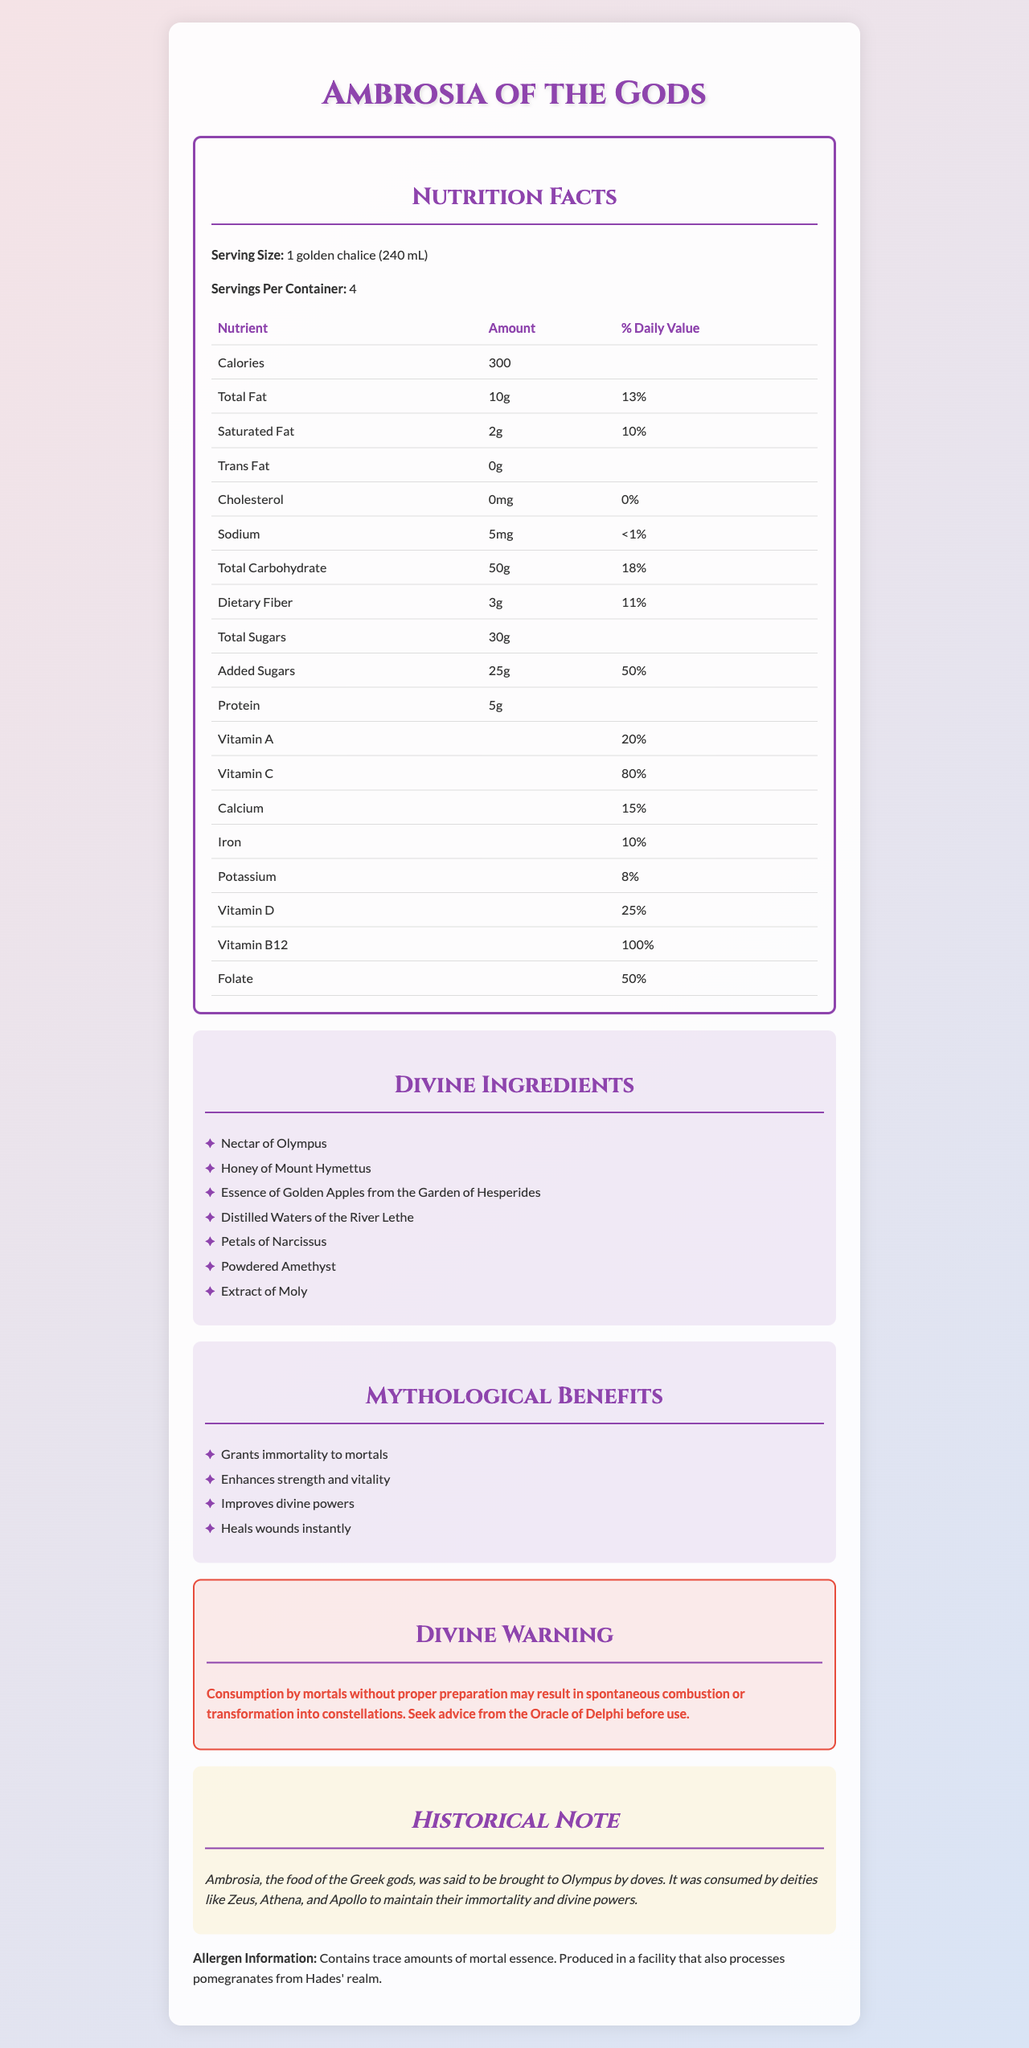What is the serving size of Ambrosia of the Gods? The serving size is clearly indicated as "1 golden chalice (240 mL)" in the Nutrition Facts section.
Answer: 1 golden chalice (240 mL) How many calories are in one serving of Ambrosia of the Gods? The Nutrition Facts section lists the calories per serving as 300.
Answer: 300 What is the daily value percentage for Vitamin C? The document shows the daily value percentage for Vitamin C as 80%.
Answer: 80% What are the mythological benefits of consuming Ambrosia of the Gods? The mythological benefits are listed in the Mythological Benefits section.
Answer: Grants immortality to mortals, Enhances strength and vitality, Improves divine powers, Heals wounds instantly What is a major warning for mortals consuming Ambrosia of the Gods? The warning is detailed under the Divine Warning section.
Answer: Consumption by mortals without proper preparation may result in spontaneous combustion or transformation into constellations How many servings are there per container of Ambrosia of the Gods? A. 2 B. 4 C. 6 The document specifies that there are 4 servings per container.
Answer: B Which ingredient is used in Ambrosia of the Gods? A. Nectar of Olympus B. Ambrosia Flowers C. Essence of Phoenix The ingredient "Nectar of Olympus" is listed in the Divine Ingredients section.
Answer: A Does Ambrosia of the Gods contain any cholesterol? The Nutrition Facts state that the cholesterol amount is 0mg, and the daily value is 0%.
Answer: No Can we determine the exact preparation method for Ambrosia of the Gods from this document? The document does not provide any details about the preparation method, only warning about its consumption.
Answer: No Summarize the entire document. The document contains detailed information about Ambrosia of the Gods, including nutrition facts, ingredients, mythological benefits, and a warning for mortal consumption. It also provides a historical context linking it to Greek gods and their consumption.
Answer: Ambrosia of the Gods is a mythical beverage inspired by Greek mythology, offering not just nutritional content but also legendary benefits such as granting immortality and enhancing divine powers. The document outlines its serving size, nutritional facts, ingredients, mythological benefits, a historical note, and a severe warning for mortal consumption. 